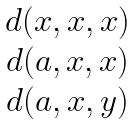Convert formula to latex. <formula><loc_0><loc_0><loc_500><loc_500>\begin{matrix} d ( x , x , x ) \\ d ( a , x , x ) \\ d ( a , x , y ) \end{matrix}</formula> 